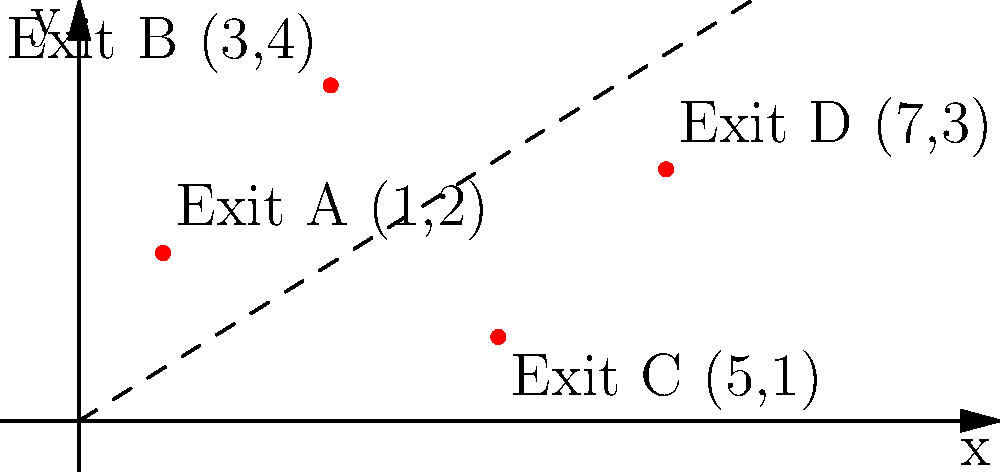You're tasked with setting up roadblocks to intercept a suspect fleeing on a highway. The highway exits are represented on a coordinate system, where each unit represents 1 mile. Given the exits A(1,2), B(3,4), C(5,1), and D(7,3), determine the optimal location for a roadblock that minimizes the maximum distance to any exit. What are the coordinates of this optimal location? To find the optimal location for the roadblock, we'll use the concept of the geometric median, which minimizes the sum of distances to all points. In this case, we're looking for a point that minimizes the maximum distance to any exit. Here's how we can approach this:

1. Observe that the optimal point is likely to be somewhere in the middle of all exits.

2. One method to approximate this point is to find the centroid of the quadrilateral formed by the four exits:
   $$ (\frac{x_A + x_B + x_C + x_D}{4}, \frac{y_A + y_B + y_C + y_D}{4}) $$
   $$ = (\frac{1 + 3 + 5 + 7}{4}, \frac{2 + 4 + 1 + 3}{4}) = (4, 2.5) $$

3. This point (4, 2.5) is a good initial guess for the optimal location.

4. To verify, we can calculate the distances from this point to each exit:
   - Distance to A: $\sqrt{(4-1)^2 + (2.5-2)^2} \approx 3.04$
   - Distance to B: $\sqrt{(4-3)^2 + (2.5-4)^2} \approx 1.80$
   - Distance to C: $\sqrt{(4-5)^2 + (2.5-1)^2} \approx 1.80$
   - Distance to D: $\sqrt{(4-7)^2 + (2.5-3)^2} \approx 3.04$

5. We can see that this point equalizes the maximum distance to the farthest exits (A and D).

6. Any other point would increase the maximum distance to at least one of the exits.

Therefore, the point (4, 2.5) is the optimal location for the roadblock.
Answer: (4, 2.5) 